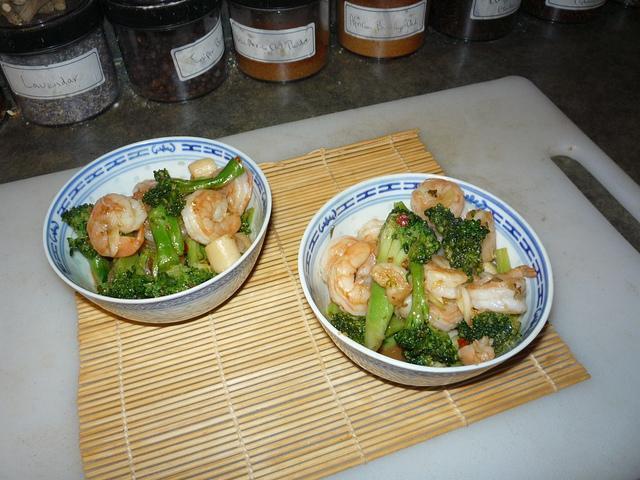If this is Chinese food how was it most likely cooked?
Answer the question by selecting the correct answer among the 4 following choices and explain your choice with a short sentence. The answer should be formatted with the following format: `Answer: choice
Rationale: rationale.`
Options: Barbecue grill, pan seared, stir fried, oven. Answer: stir fried.
Rationale: Food like this is usually cooked in a wok with oil as it's stirred. 